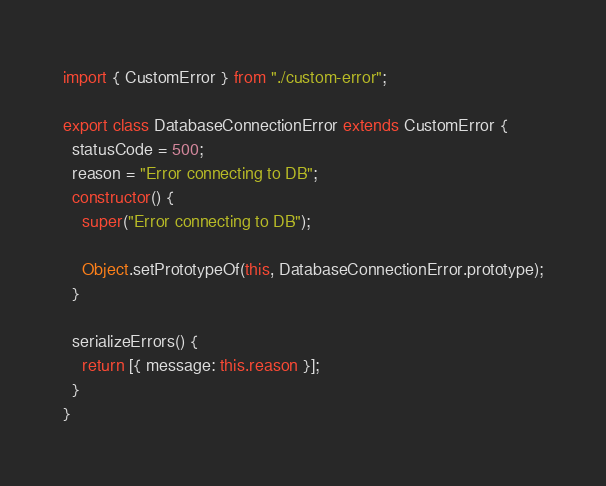<code> <loc_0><loc_0><loc_500><loc_500><_TypeScript_>import { CustomError } from "./custom-error";

export class DatabaseConnectionError extends CustomError {
  statusCode = 500;
  reason = "Error connecting to DB";
  constructor() {
    super("Error connecting to DB");

    Object.setPrototypeOf(this, DatabaseConnectionError.prototype);
  }

  serializeErrors() {
    return [{ message: this.reason }];
  }
}
</code> 